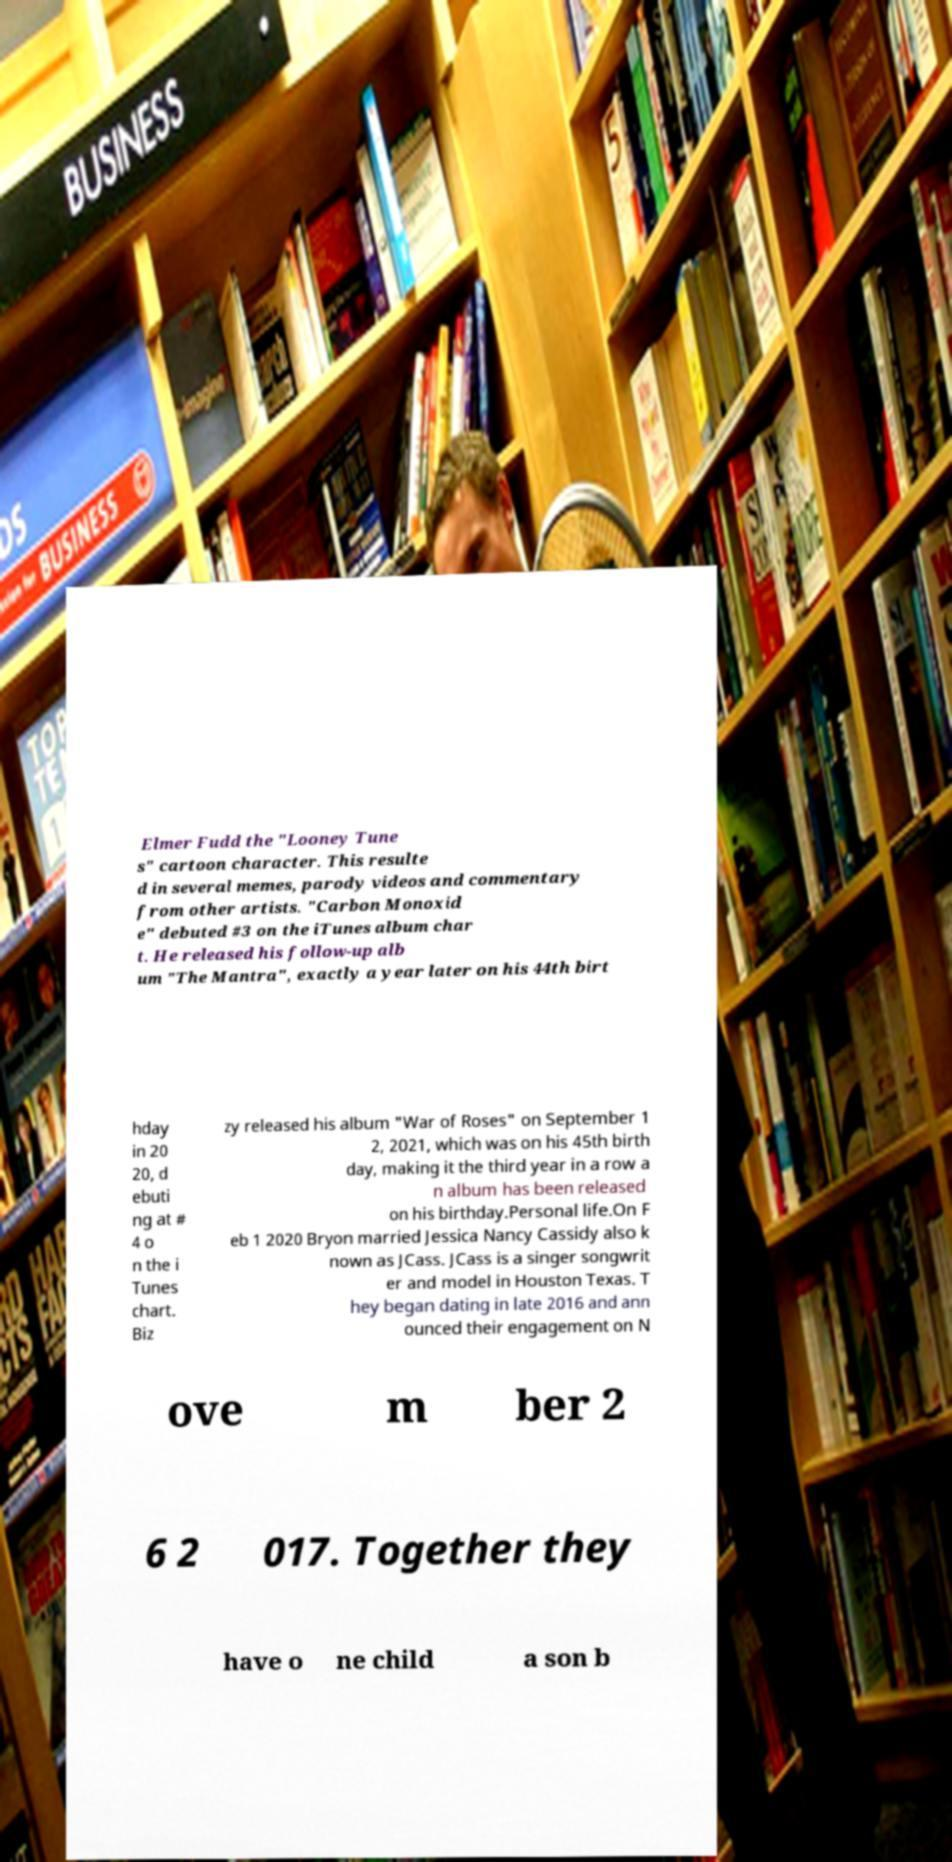Please identify and transcribe the text found in this image. Elmer Fudd the "Looney Tune s" cartoon character. This resulte d in several memes, parody videos and commentary from other artists. "Carbon Monoxid e" debuted #3 on the iTunes album char t. He released his follow-up alb um "The Mantra", exactly a year later on his 44th birt hday in 20 20, d ebuti ng at # 4 o n the i Tunes chart. Biz zy released his album "War of Roses" on September 1 2, 2021, which was on his 45th birth day, making it the third year in a row a n album has been released on his birthday.Personal life.On F eb 1 2020 Bryon married Jessica Nancy Cassidy also k nown as JCass. JCass is a singer songwrit er and model in Houston Texas. T hey began dating in late 2016 and ann ounced their engagement on N ove m ber 2 6 2 017. Together they have o ne child a son b 